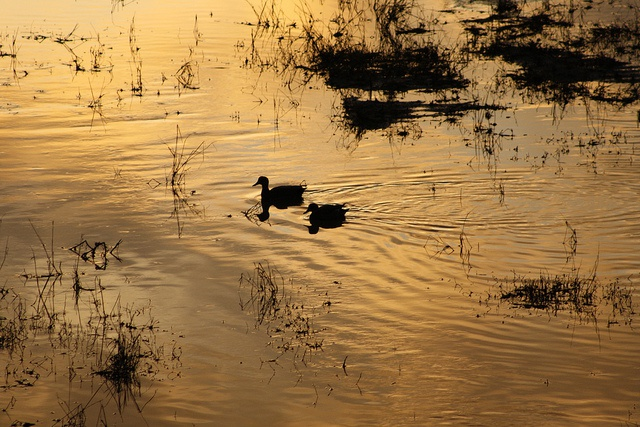Describe the objects in this image and their specific colors. I can see bird in tan, black, and maroon tones and bird in tan, black, maroon, gray, and brown tones in this image. 